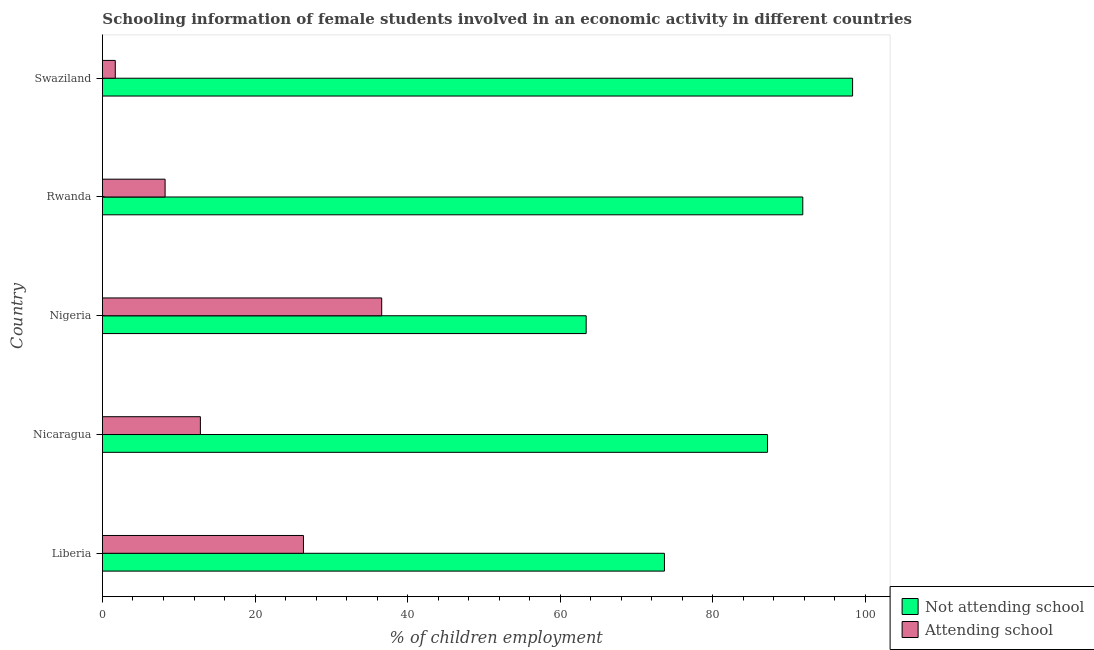How many different coloured bars are there?
Offer a terse response. 2. Are the number of bars on each tick of the Y-axis equal?
Make the answer very short. Yes. What is the label of the 3rd group of bars from the top?
Make the answer very short. Nigeria. What is the percentage of employed females who are attending school in Swaziland?
Offer a terse response. 1.68. Across all countries, what is the maximum percentage of employed females who are attending school?
Provide a succinct answer. 36.6. Across all countries, what is the minimum percentage of employed females who are attending school?
Your answer should be compact. 1.68. In which country was the percentage of employed females who are not attending school maximum?
Ensure brevity in your answer.  Swaziland. In which country was the percentage of employed females who are attending school minimum?
Make the answer very short. Swaziland. What is the total percentage of employed females who are not attending school in the graph?
Offer a very short reply. 414.33. What is the difference between the percentage of employed females who are attending school in Liberia and that in Rwanda?
Your response must be concise. 18.13. What is the difference between the percentage of employed females who are attending school in Nigeria and the percentage of employed females who are not attending school in Nicaragua?
Your response must be concise. -50.56. What is the average percentage of employed females who are attending school per country?
Your answer should be compact. 17.13. What is the difference between the percentage of employed females who are attending school and percentage of employed females who are not attending school in Liberia?
Ensure brevity in your answer.  -47.31. In how many countries, is the percentage of employed females who are not attending school greater than 96 %?
Keep it short and to the point. 1. What is the ratio of the percentage of employed females who are not attending school in Nigeria to that in Swaziland?
Your answer should be very brief. 0.65. Is the percentage of employed females who are attending school in Liberia less than that in Nigeria?
Your answer should be very brief. Yes. What is the difference between the highest and the second highest percentage of employed females who are not attending school?
Your answer should be very brief. 6.53. What is the difference between the highest and the lowest percentage of employed females who are not attending school?
Provide a short and direct response. 34.92. In how many countries, is the percentage of employed females who are not attending school greater than the average percentage of employed females who are not attending school taken over all countries?
Keep it short and to the point. 3. What does the 2nd bar from the top in Nigeria represents?
Ensure brevity in your answer.  Not attending school. What does the 2nd bar from the bottom in Nicaragua represents?
Keep it short and to the point. Attending school. How many bars are there?
Your answer should be compact. 10. Are all the bars in the graph horizontal?
Offer a very short reply. Yes. How many countries are there in the graph?
Ensure brevity in your answer.  5. What is the difference between two consecutive major ticks on the X-axis?
Make the answer very short. 20. Are the values on the major ticks of X-axis written in scientific E-notation?
Ensure brevity in your answer.  No. Does the graph contain any zero values?
Offer a terse response. No. Does the graph contain grids?
Your answer should be very brief. No. Where does the legend appear in the graph?
Give a very brief answer. Bottom right. How many legend labels are there?
Offer a very short reply. 2. How are the legend labels stacked?
Offer a terse response. Vertical. What is the title of the graph?
Provide a short and direct response. Schooling information of female students involved in an economic activity in different countries. What is the label or title of the X-axis?
Your answer should be very brief. % of children employment. What is the label or title of the Y-axis?
Offer a very short reply. Country. What is the % of children employment of Not attending school in Liberia?
Give a very brief answer. 73.66. What is the % of children employment in Attending school in Liberia?
Your answer should be compact. 26.34. What is the % of children employment of Not attending school in Nicaragua?
Provide a succinct answer. 87.16. What is the % of children employment of Attending school in Nicaragua?
Ensure brevity in your answer.  12.84. What is the % of children employment in Not attending school in Nigeria?
Keep it short and to the point. 63.4. What is the % of children employment in Attending school in Nigeria?
Offer a terse response. 36.6. What is the % of children employment in Not attending school in Rwanda?
Provide a short and direct response. 91.79. What is the % of children employment of Attending school in Rwanda?
Keep it short and to the point. 8.21. What is the % of children employment of Not attending school in Swaziland?
Give a very brief answer. 98.32. What is the % of children employment of Attending school in Swaziland?
Provide a succinct answer. 1.68. Across all countries, what is the maximum % of children employment of Not attending school?
Give a very brief answer. 98.32. Across all countries, what is the maximum % of children employment of Attending school?
Give a very brief answer. 36.6. Across all countries, what is the minimum % of children employment of Not attending school?
Provide a succinct answer. 63.4. Across all countries, what is the minimum % of children employment in Attending school?
Your response must be concise. 1.68. What is the total % of children employment of Not attending school in the graph?
Keep it short and to the point. 414.33. What is the total % of children employment in Attending school in the graph?
Provide a short and direct response. 85.67. What is the difference between the % of children employment of Not attending school in Liberia and that in Nicaragua?
Make the answer very short. -13.51. What is the difference between the % of children employment of Attending school in Liberia and that in Nicaragua?
Your answer should be compact. 13.51. What is the difference between the % of children employment of Not attending school in Liberia and that in Nigeria?
Your answer should be very brief. 10.26. What is the difference between the % of children employment of Attending school in Liberia and that in Nigeria?
Ensure brevity in your answer.  -10.26. What is the difference between the % of children employment in Not attending school in Liberia and that in Rwanda?
Provide a short and direct response. -18.13. What is the difference between the % of children employment in Attending school in Liberia and that in Rwanda?
Make the answer very short. 18.13. What is the difference between the % of children employment in Not attending school in Liberia and that in Swaziland?
Your answer should be compact. -24.66. What is the difference between the % of children employment in Attending school in Liberia and that in Swaziland?
Provide a short and direct response. 24.66. What is the difference between the % of children employment of Not attending school in Nicaragua and that in Nigeria?
Keep it short and to the point. 23.76. What is the difference between the % of children employment of Attending school in Nicaragua and that in Nigeria?
Ensure brevity in your answer.  -23.76. What is the difference between the % of children employment in Not attending school in Nicaragua and that in Rwanda?
Provide a short and direct response. -4.63. What is the difference between the % of children employment in Attending school in Nicaragua and that in Rwanda?
Your answer should be compact. 4.63. What is the difference between the % of children employment of Not attending school in Nicaragua and that in Swaziland?
Offer a terse response. -11.16. What is the difference between the % of children employment of Attending school in Nicaragua and that in Swaziland?
Offer a very short reply. 11.16. What is the difference between the % of children employment of Not attending school in Nigeria and that in Rwanda?
Provide a short and direct response. -28.39. What is the difference between the % of children employment of Attending school in Nigeria and that in Rwanda?
Offer a very short reply. 28.39. What is the difference between the % of children employment in Not attending school in Nigeria and that in Swaziland?
Make the answer very short. -34.92. What is the difference between the % of children employment of Attending school in Nigeria and that in Swaziland?
Provide a succinct answer. 34.92. What is the difference between the % of children employment of Not attending school in Rwanda and that in Swaziland?
Keep it short and to the point. -6.53. What is the difference between the % of children employment in Attending school in Rwanda and that in Swaziland?
Make the answer very short. 6.53. What is the difference between the % of children employment in Not attending school in Liberia and the % of children employment in Attending school in Nicaragua?
Provide a short and direct response. 60.82. What is the difference between the % of children employment in Not attending school in Liberia and the % of children employment in Attending school in Nigeria?
Your answer should be very brief. 37.06. What is the difference between the % of children employment of Not attending school in Liberia and the % of children employment of Attending school in Rwanda?
Provide a short and direct response. 65.45. What is the difference between the % of children employment in Not attending school in Liberia and the % of children employment in Attending school in Swaziland?
Make the answer very short. 71.98. What is the difference between the % of children employment of Not attending school in Nicaragua and the % of children employment of Attending school in Nigeria?
Offer a terse response. 50.56. What is the difference between the % of children employment in Not attending school in Nicaragua and the % of children employment in Attending school in Rwanda?
Provide a short and direct response. 78.96. What is the difference between the % of children employment in Not attending school in Nicaragua and the % of children employment in Attending school in Swaziland?
Your response must be concise. 85.48. What is the difference between the % of children employment in Not attending school in Nigeria and the % of children employment in Attending school in Rwanda?
Provide a succinct answer. 55.19. What is the difference between the % of children employment in Not attending school in Nigeria and the % of children employment in Attending school in Swaziland?
Give a very brief answer. 61.72. What is the difference between the % of children employment in Not attending school in Rwanda and the % of children employment in Attending school in Swaziland?
Ensure brevity in your answer.  90.11. What is the average % of children employment in Not attending school per country?
Your response must be concise. 82.87. What is the average % of children employment in Attending school per country?
Your answer should be very brief. 17.13. What is the difference between the % of children employment in Not attending school and % of children employment in Attending school in Liberia?
Keep it short and to the point. 47.31. What is the difference between the % of children employment in Not attending school and % of children employment in Attending school in Nicaragua?
Ensure brevity in your answer.  74.33. What is the difference between the % of children employment in Not attending school and % of children employment in Attending school in Nigeria?
Offer a very short reply. 26.8. What is the difference between the % of children employment of Not attending school and % of children employment of Attending school in Rwanda?
Provide a succinct answer. 83.58. What is the difference between the % of children employment of Not attending school and % of children employment of Attending school in Swaziland?
Make the answer very short. 96.64. What is the ratio of the % of children employment of Not attending school in Liberia to that in Nicaragua?
Offer a terse response. 0.84. What is the ratio of the % of children employment in Attending school in Liberia to that in Nicaragua?
Your answer should be very brief. 2.05. What is the ratio of the % of children employment in Not attending school in Liberia to that in Nigeria?
Your response must be concise. 1.16. What is the ratio of the % of children employment in Attending school in Liberia to that in Nigeria?
Keep it short and to the point. 0.72. What is the ratio of the % of children employment of Not attending school in Liberia to that in Rwanda?
Give a very brief answer. 0.8. What is the ratio of the % of children employment of Attending school in Liberia to that in Rwanda?
Make the answer very short. 3.21. What is the ratio of the % of children employment in Not attending school in Liberia to that in Swaziland?
Offer a very short reply. 0.75. What is the ratio of the % of children employment in Attending school in Liberia to that in Swaziland?
Provide a succinct answer. 15.68. What is the ratio of the % of children employment in Not attending school in Nicaragua to that in Nigeria?
Ensure brevity in your answer.  1.37. What is the ratio of the % of children employment of Attending school in Nicaragua to that in Nigeria?
Ensure brevity in your answer.  0.35. What is the ratio of the % of children employment in Not attending school in Nicaragua to that in Rwanda?
Offer a very short reply. 0.95. What is the ratio of the % of children employment of Attending school in Nicaragua to that in Rwanda?
Provide a succinct answer. 1.56. What is the ratio of the % of children employment of Not attending school in Nicaragua to that in Swaziland?
Ensure brevity in your answer.  0.89. What is the ratio of the % of children employment of Attending school in Nicaragua to that in Swaziland?
Your answer should be very brief. 7.64. What is the ratio of the % of children employment of Not attending school in Nigeria to that in Rwanda?
Ensure brevity in your answer.  0.69. What is the ratio of the % of children employment in Attending school in Nigeria to that in Rwanda?
Your response must be concise. 4.46. What is the ratio of the % of children employment of Not attending school in Nigeria to that in Swaziland?
Make the answer very short. 0.64. What is the ratio of the % of children employment in Attending school in Nigeria to that in Swaziland?
Offer a terse response. 21.79. What is the ratio of the % of children employment of Not attending school in Rwanda to that in Swaziland?
Your answer should be very brief. 0.93. What is the ratio of the % of children employment in Attending school in Rwanda to that in Swaziland?
Ensure brevity in your answer.  4.89. What is the difference between the highest and the second highest % of children employment of Not attending school?
Make the answer very short. 6.53. What is the difference between the highest and the second highest % of children employment of Attending school?
Keep it short and to the point. 10.26. What is the difference between the highest and the lowest % of children employment in Not attending school?
Keep it short and to the point. 34.92. What is the difference between the highest and the lowest % of children employment of Attending school?
Provide a succinct answer. 34.92. 